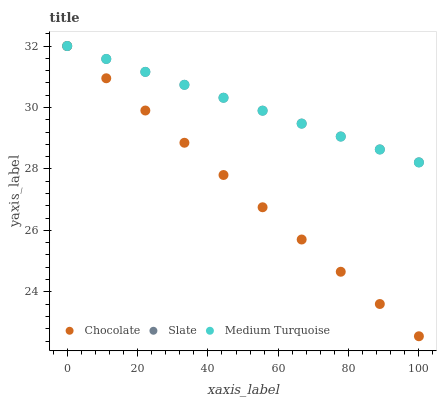Does Chocolate have the minimum area under the curve?
Answer yes or no. Yes. Does Slate have the maximum area under the curve?
Answer yes or no. Yes. Does Medium Turquoise have the minimum area under the curve?
Answer yes or no. No. Does Medium Turquoise have the maximum area under the curve?
Answer yes or no. No. Is Medium Turquoise the smoothest?
Answer yes or no. Yes. Is Chocolate the roughest?
Answer yes or no. Yes. Is Chocolate the smoothest?
Answer yes or no. No. Is Medium Turquoise the roughest?
Answer yes or no. No. Does Chocolate have the lowest value?
Answer yes or no. Yes. Does Medium Turquoise have the lowest value?
Answer yes or no. No. Does Chocolate have the highest value?
Answer yes or no. Yes. Does Slate intersect Chocolate?
Answer yes or no. Yes. Is Slate less than Chocolate?
Answer yes or no. No. Is Slate greater than Chocolate?
Answer yes or no. No. 